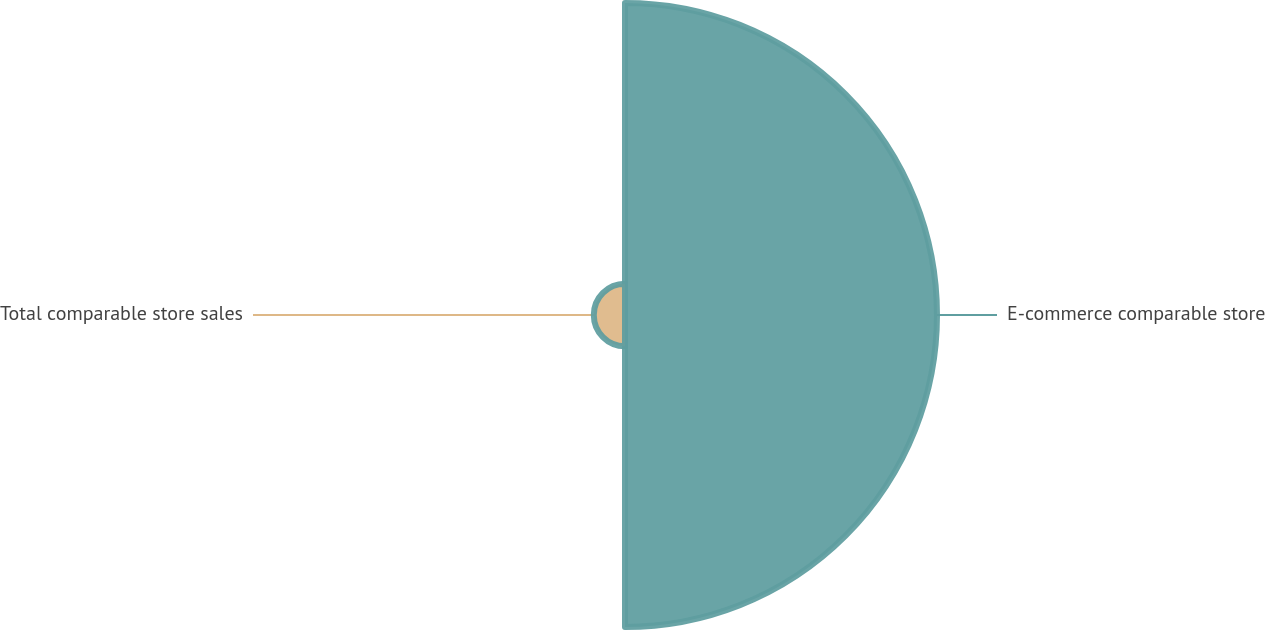<chart> <loc_0><loc_0><loc_500><loc_500><pie_chart><fcel>E-commerce comparable store<fcel>Total comparable store sales<nl><fcel>90.91%<fcel>9.09%<nl></chart> 